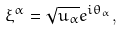<formula> <loc_0><loc_0><loc_500><loc_500>\xi ^ { \alpha } = \sqrt { u _ { \alpha } } e ^ { i \theta _ { \alpha } } ,</formula> 